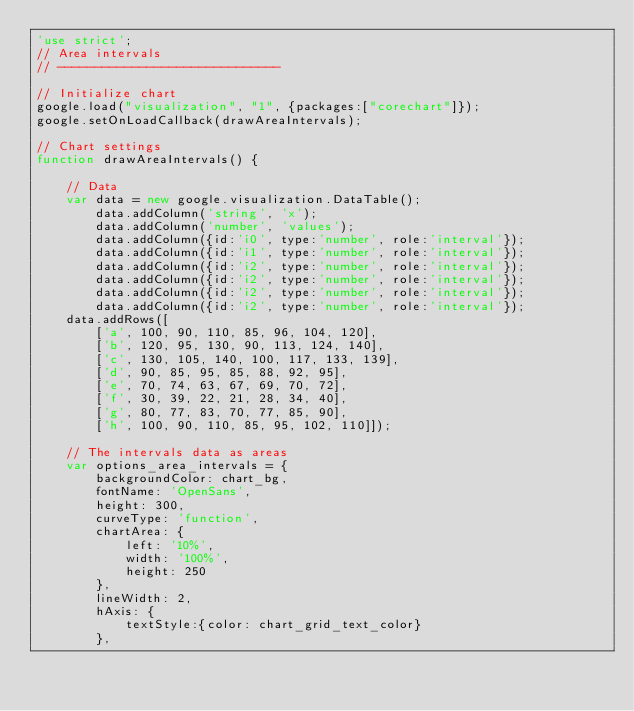<code> <loc_0><loc_0><loc_500><loc_500><_JavaScript_>'use strict';
// Area intervals
// ------------------------------

// Initialize chart
google.load("visualization", "1", {packages:["corechart"]});
google.setOnLoadCallback(drawAreaIntervals);

// Chart settings
function drawAreaIntervals() {

    // Data
    var data = new google.visualization.DataTable();
        data.addColumn('string', 'x');
        data.addColumn('number', 'values');
        data.addColumn({id:'i0', type:'number', role:'interval'});
        data.addColumn({id:'i1', type:'number', role:'interval'});
        data.addColumn({id:'i2', type:'number', role:'interval'});
        data.addColumn({id:'i2', type:'number', role:'interval'});
        data.addColumn({id:'i2', type:'number', role:'interval'});
        data.addColumn({id:'i2', type:'number', role:'interval'});
    data.addRows([
        ['a', 100, 90, 110, 85, 96, 104, 120],
        ['b', 120, 95, 130, 90, 113, 124, 140],
        ['c', 130, 105, 140, 100, 117, 133, 139],
        ['d', 90, 85, 95, 85, 88, 92, 95],
        ['e', 70, 74, 63, 67, 69, 70, 72],
        ['f', 30, 39, 22, 21, 28, 34, 40],
        ['g', 80, 77, 83, 70, 77, 85, 90],
        ['h', 100, 90, 110, 85, 95, 102, 110]]);

    // The intervals data as areas
    var options_area_intervals = {
        backgroundColor: chart_bg,
        fontName: 'OpenSans',
        height: 300,
        curveType: 'function',
        chartArea: {
            left: '10%',
            width: '100%',
            height: 250
        },
        lineWidth: 2,
        hAxis: {
            textStyle:{color: chart_grid_text_color}
        },</code> 